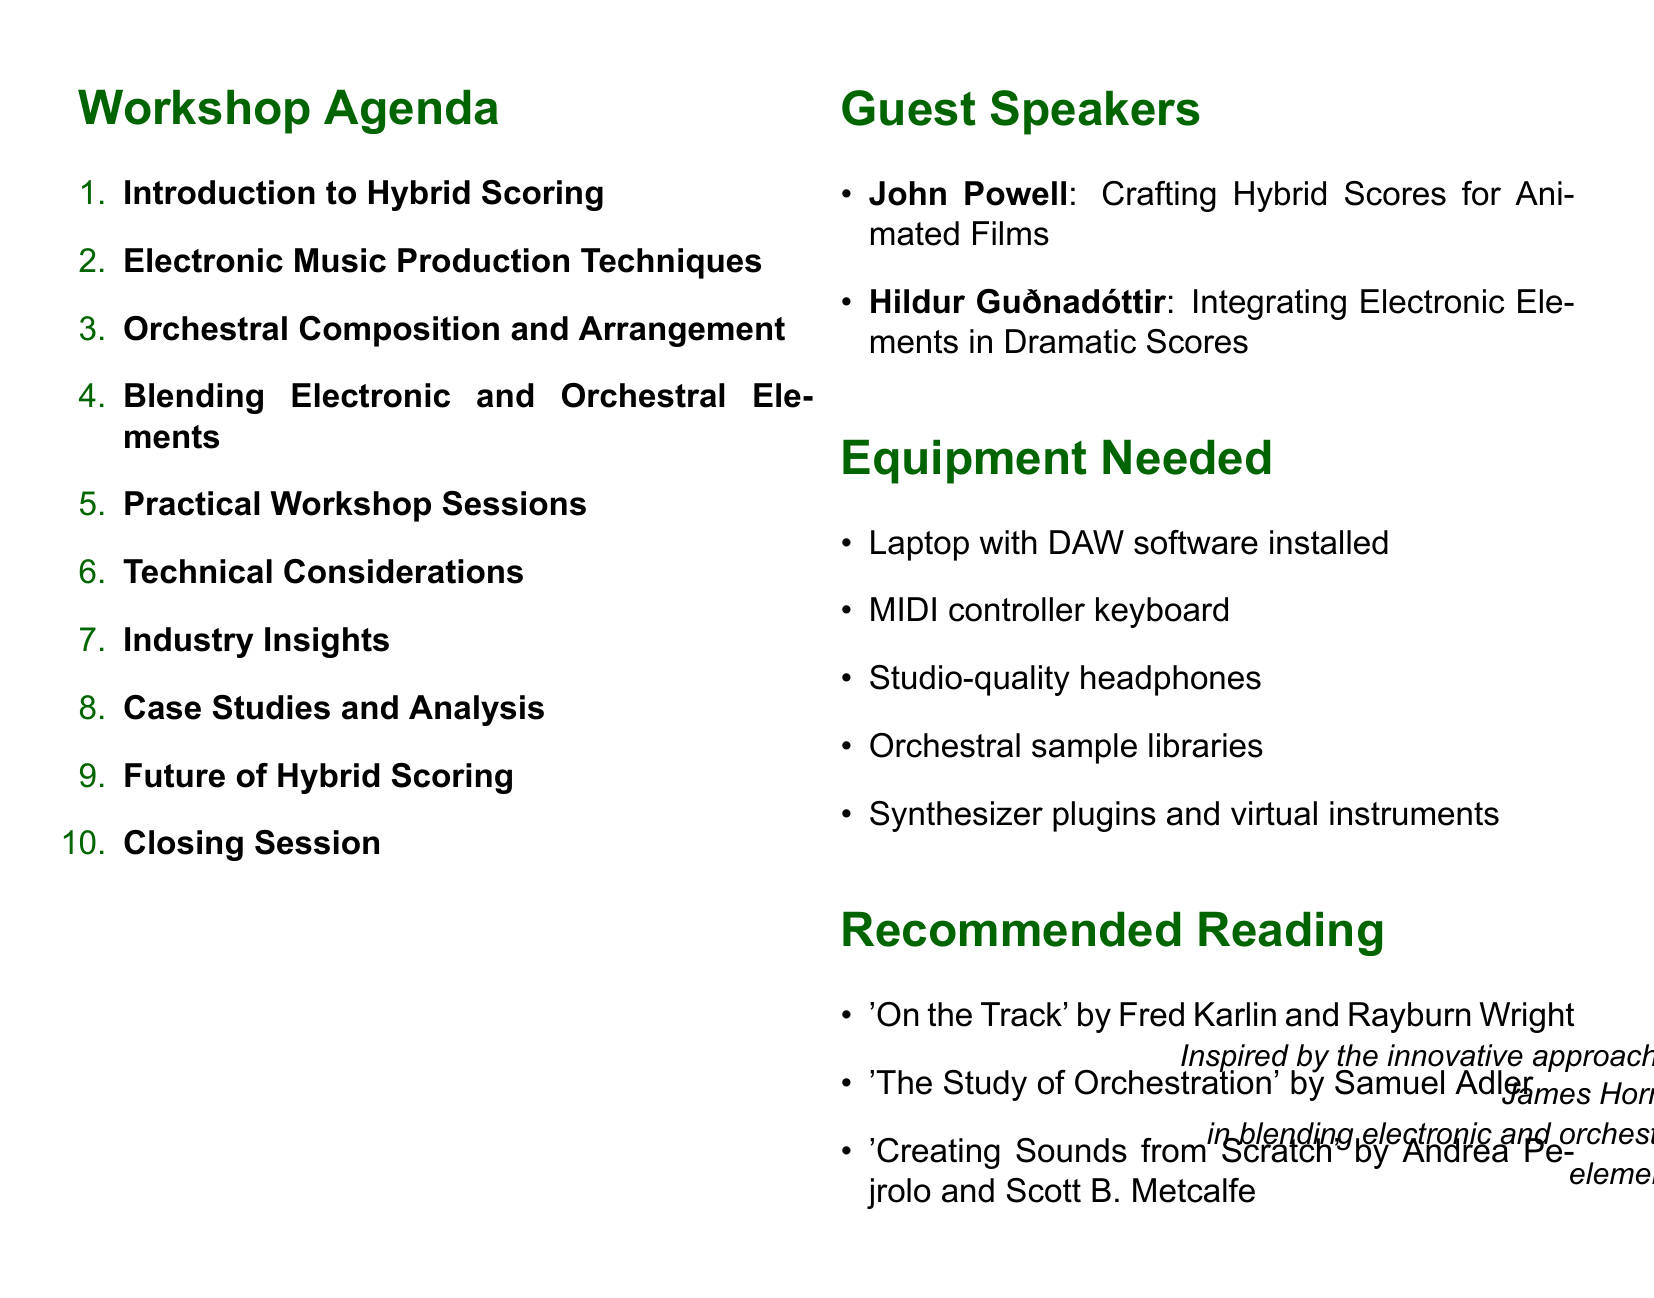What is the title of the workshop? The title of the workshop is explicitly stated at the beginning of the document.
Answer: Bridging Worlds: Integrating Electronic and Orchestral Elements in Film Scores How long is the workshop? The duration of the workshop is mentioned clearly.
Answer: 2-day workshop Who is the target audience for the workshop? The target audience is specified in the document.
Answer: Experienced film composers and advanced music students What are the names of the guest speakers? The document lists the names of the guest speakers along with their topics.
Answer: John Powell, Hildur Guðnadóttir What is one of the subtopics covered in "Blending Electronic and Orchestral Elements"? Subtopics are listed under each section and can help identify specifics regarding the content.
Answer: Layering synthesized and acoustic instruments What is a practical workshop session activity related to James Horner? The document outlines practical activities that are part of the workshop agenda.
Answer: Recreating a cue from James Horner's Titanic with added electronic elements What equipment is needed for the workshop? A section in the document lists the required equipment.
Answer: Laptop with DAW software installed What trend is mentioned in "Industry Insights"? This section covers trends in the context of hybrid scoring, providing insights into current practices.
Answer: Current trends in hybrid scoring for films and TV What emerging technology is discussed in the future of hybrid scoring? The document addresses emerging technologies within the specific context of the future in scoring.
Answer: AI-assisted composition and virtual instruments 